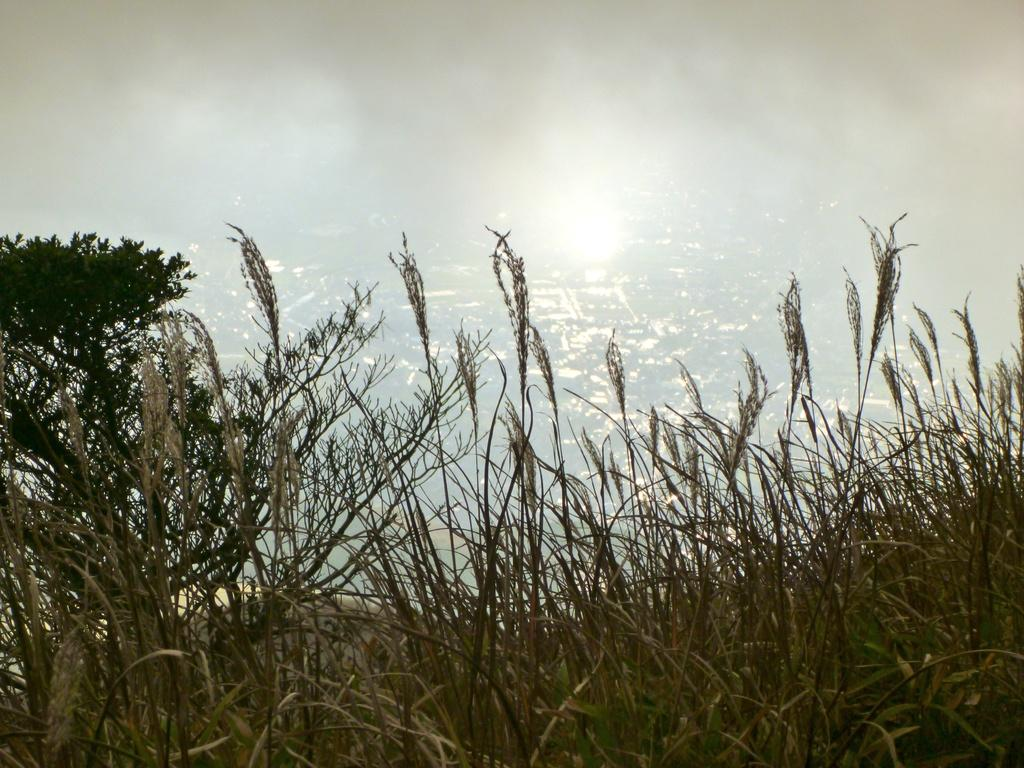What type of living organisms can be seen in the image? Plants can be seen in the image. What else is present in the image besides plants? There is water visible in the image. Can you describe the background of the image? The background of the image is blurred. How many sheep are visible in the image? There are no sheep present in the image. What type of quicksand can be seen in the image? There is no quicksand present in the image. 